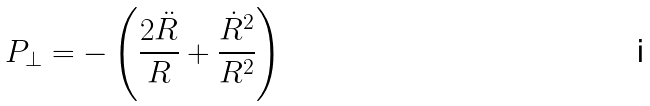<formula> <loc_0><loc_0><loc_500><loc_500>P _ { \bot } = - \left ( \frac { 2 \ddot { R } } { R } + \frac { \dot { R } ^ { 2 } } { R ^ { 2 } } \right )</formula> 